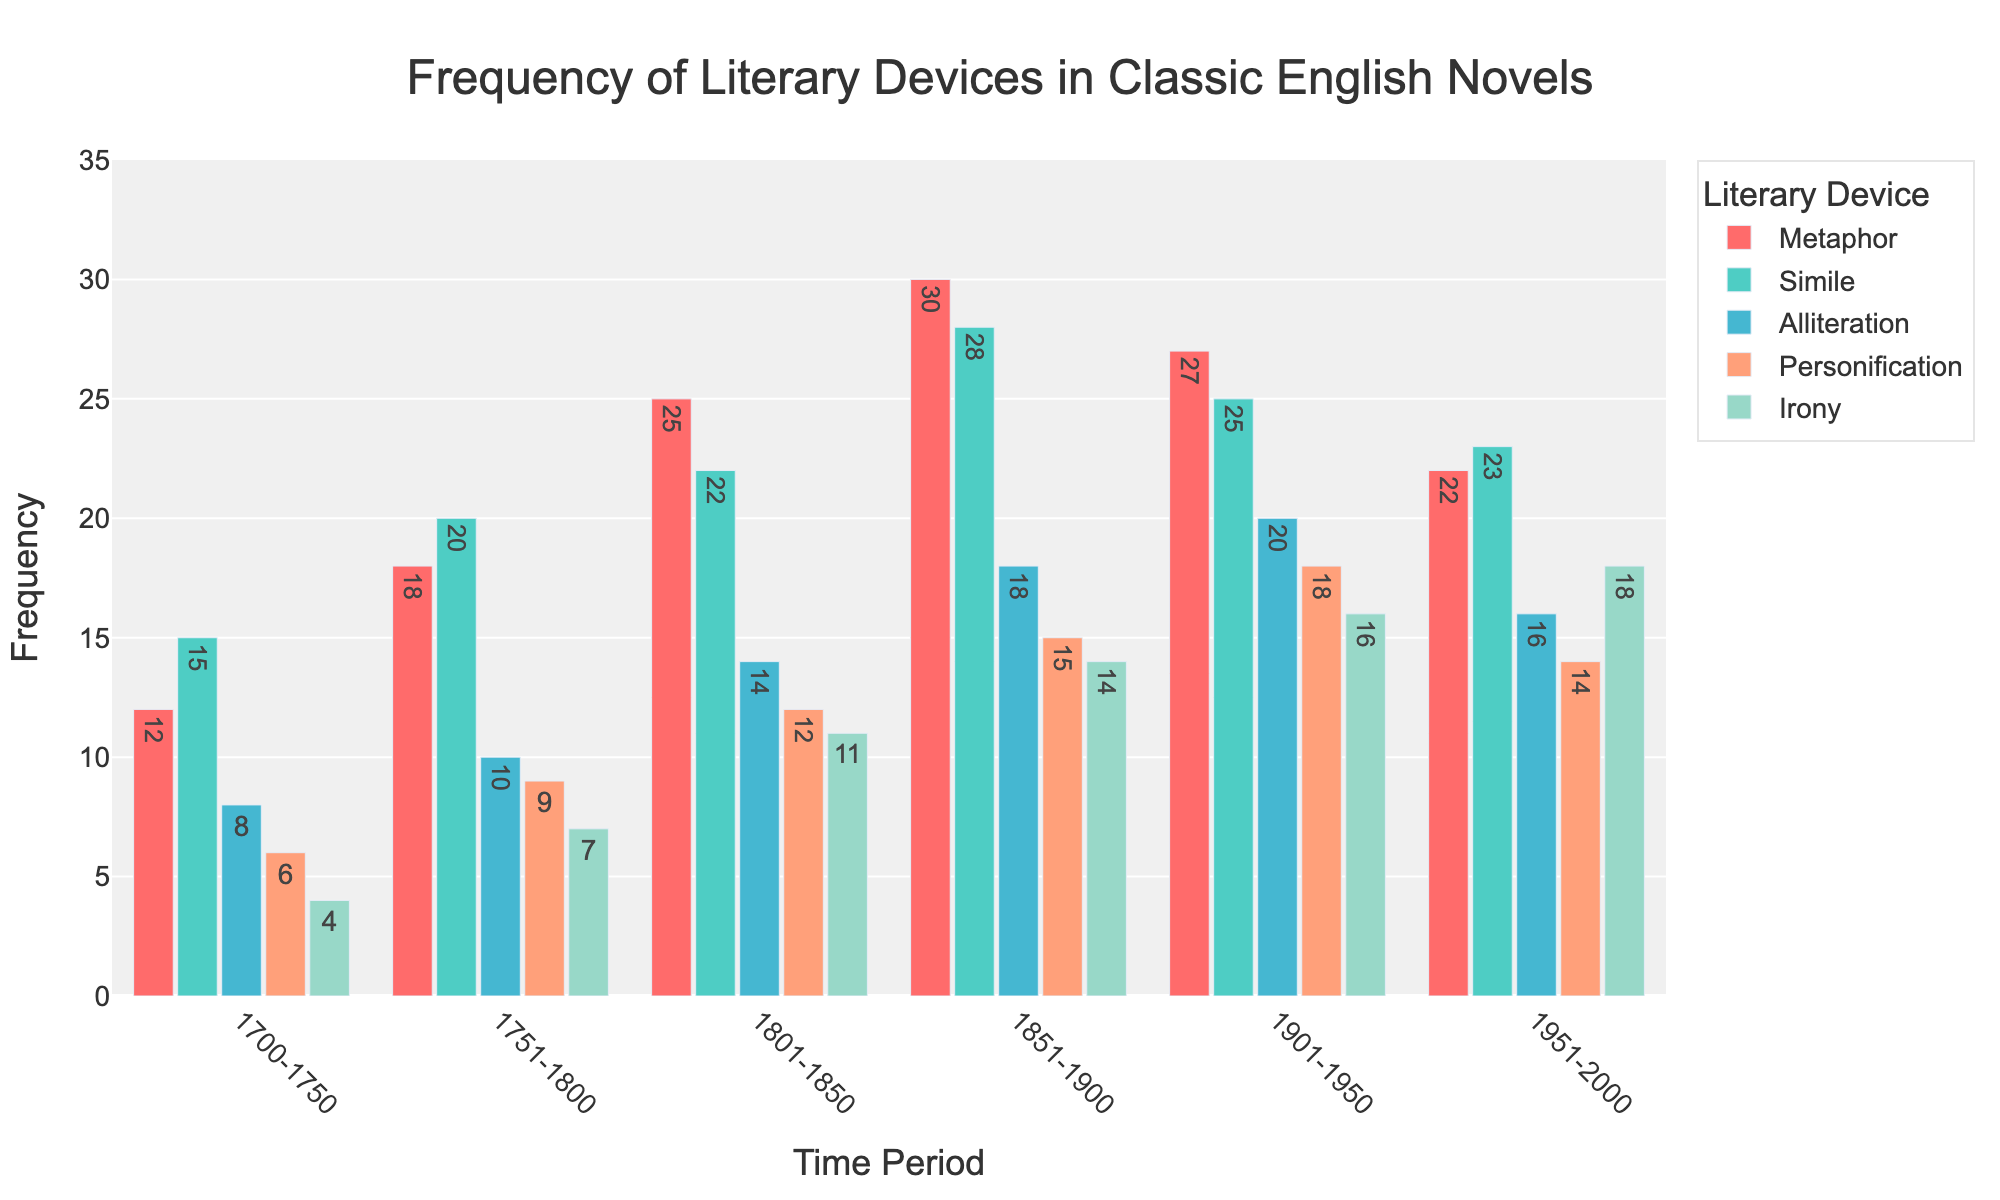What time period has the highest occurrence of metaphor? Look at the bars representing metaphor. The bar for 1851-1900 is the tallest.
Answer: 1851-1900 Which literary device had the lowest frequency in the 1700-1750 period? Compare the heights for each device within the 1700-1750 period. Personification has the shortest bar.
Answer: Personification Between 1901-1950 and 1951-2000, which period had a higher frequency of irony? Compare the bars representing irony for the periods 1901-1950 and 1951-2000. 1951-2000 has a higher bar.
Answer: 1951-2000 How many metaphors were used from 1801 to 1900 in total? Add the frequencies for metaphors from 1801-1850 and 1851-1900 (25 + 30).
Answer: 55 Is the frequency of similes in 1751-1800 greater than the frequency of alliterations in 1951-2000? Compare the bars: Simile in 1751-1800 is 20, Alliteration in 1951-2000 is 16. 20 is greater than 16.
Answer: Yes What is the average number of personifications used across all periods? Sum all personification frequencies (6 + 9 + 12 + 15 + 18 + 14 = 74) and divide by the number of periods (6).
Answer: 12.33 In which time period is the sum of metaphors and personifications greater than 40? Identify periods where the sum of metaphors and personifications is more than 40:
1700-1750: 12 + 6 = 18,
1751-1800: 18 + 9 = 27,
1801-1850: 25 + 12 = 37,
1851-1900: 30 + 15 = 45,
1901-1950: 27 + 18 = 45,
1951-2000: 22 + 14 = 36. The periods are 1851-1900 and 1901-1950.
Answer: 1851-1900, 1901-1950 